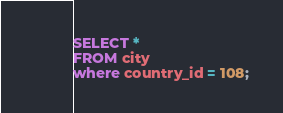<code> <loc_0><loc_0><loc_500><loc_500><_SQL_>
SELECT *
FROM city
where country_id = 108;</code> 